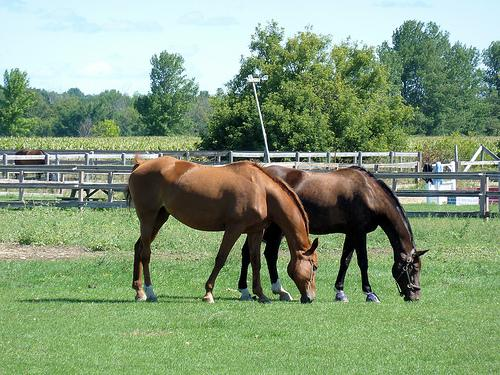Choose the main subjects of the image and describe their appearance. The main subjects are one light brown horse with its back legs crossed and one dark brown horse, both with their heads down and eating grass. Describe the environment that the main subjects are in, including the surrounding features. The horses are in a lush green field with short grass, a small wooden fence behind them, and tall trees with green leaves in the distance. Illustrate the central action taking place in the photograph. The central action of the photograph is two horses, one light brown and the other dark brown, grazing on the green grass in a field. Provide a brief description of the scene in the image. Two brown horses, one light and one dark, are grazing in a green field with short grass and a small wooden fence behind them. Identify the main subjects and their colors in the image and briefly describe their activity. The image features a light brown horse and a dark brown horse, both grazing on the grass in a green field. What are the key characteristics of the main subjects and their environment? The main subjects are two horses with different shades of brown, grazing in a field with green grass, a wooden fence, and distant trees. Provide an overall summary of what is represented in the image. The image shows two different colored horses, one light brown and the other dark brown, grazing in a green field with a fence and trees in the background. Explain the setting of the image and the activity occurring. In a grassy field during the day, two horses – one light brown and the other dark brown – are both feeding on the grass. What is the primary focus of the image, and what is its activity? The primary focus of the image is two horses grazing in a field, with one horse being light brown and the other dark brown. Mention the two most dominant objects in the image along with their colors and actions. A light brown horse and a dark brown horse are both grazing in a green field filled with grass. 